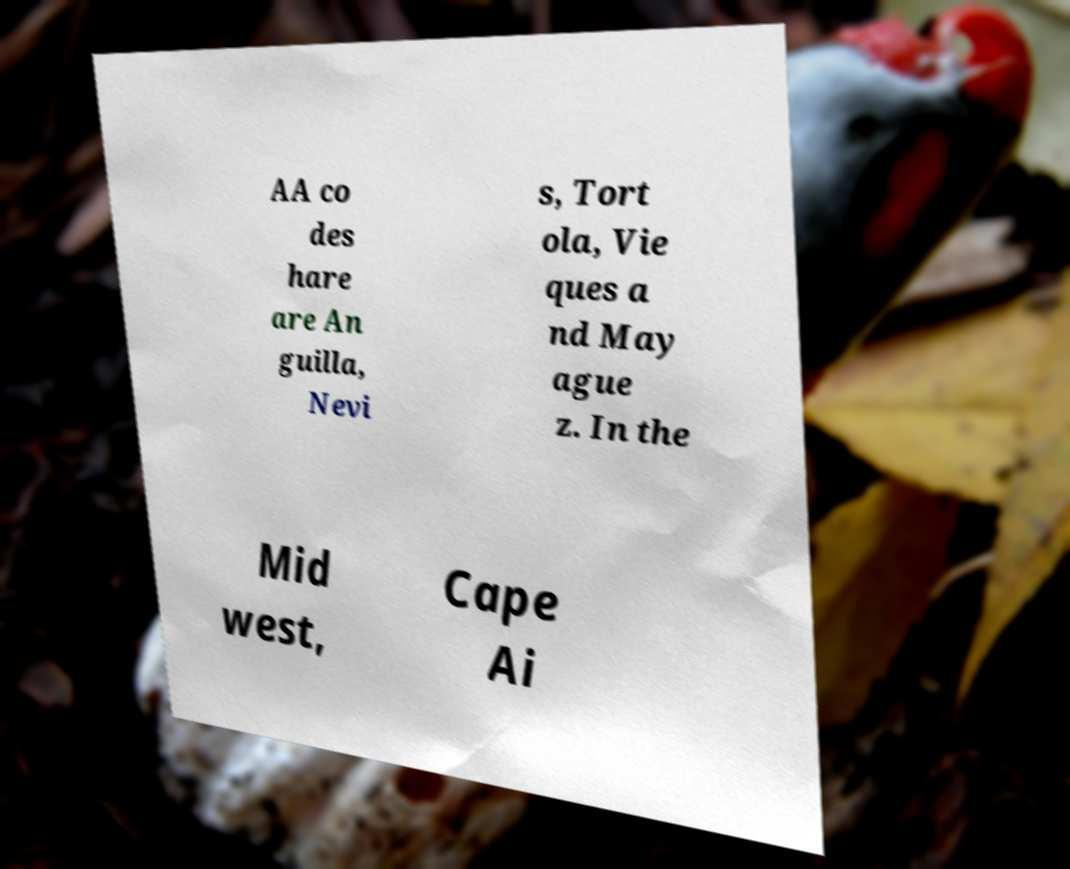What messages or text are displayed in this image? I need them in a readable, typed format. AA co des hare are An guilla, Nevi s, Tort ola, Vie ques a nd May ague z. In the Mid west, Cape Ai 